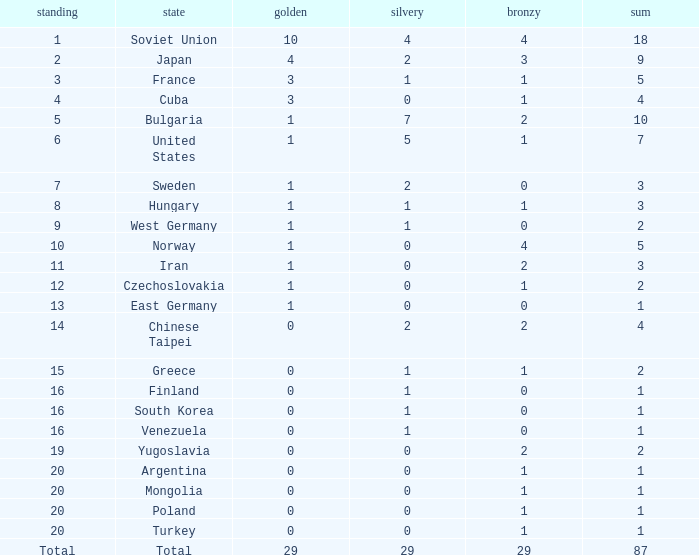Which rank has 1 silver medal and more than 1 gold medal? 3.0. Parse the full table. {'header': ['standing', 'state', 'golden', 'silvery', 'bronzy', 'sum'], 'rows': [['1', 'Soviet Union', '10', '4', '4', '18'], ['2', 'Japan', '4', '2', '3', '9'], ['3', 'France', '3', '1', '1', '5'], ['4', 'Cuba', '3', '0', '1', '4'], ['5', 'Bulgaria', '1', '7', '2', '10'], ['6', 'United States', '1', '5', '1', '7'], ['7', 'Sweden', '1', '2', '0', '3'], ['8', 'Hungary', '1', '1', '1', '3'], ['9', 'West Germany', '1', '1', '0', '2'], ['10', 'Norway', '1', '0', '4', '5'], ['11', 'Iran', '1', '0', '2', '3'], ['12', 'Czechoslovakia', '1', '0', '1', '2'], ['13', 'East Germany', '1', '0', '0', '1'], ['14', 'Chinese Taipei', '0', '2', '2', '4'], ['15', 'Greece', '0', '1', '1', '2'], ['16', 'Finland', '0', '1', '0', '1'], ['16', 'South Korea', '0', '1', '0', '1'], ['16', 'Venezuela', '0', '1', '0', '1'], ['19', 'Yugoslavia', '0', '0', '2', '2'], ['20', 'Argentina', '0', '0', '1', '1'], ['20', 'Mongolia', '0', '0', '1', '1'], ['20', 'Poland', '0', '0', '1', '1'], ['20', 'Turkey', '0', '0', '1', '1'], ['Total', 'Total', '29', '29', '29', '87']]} 